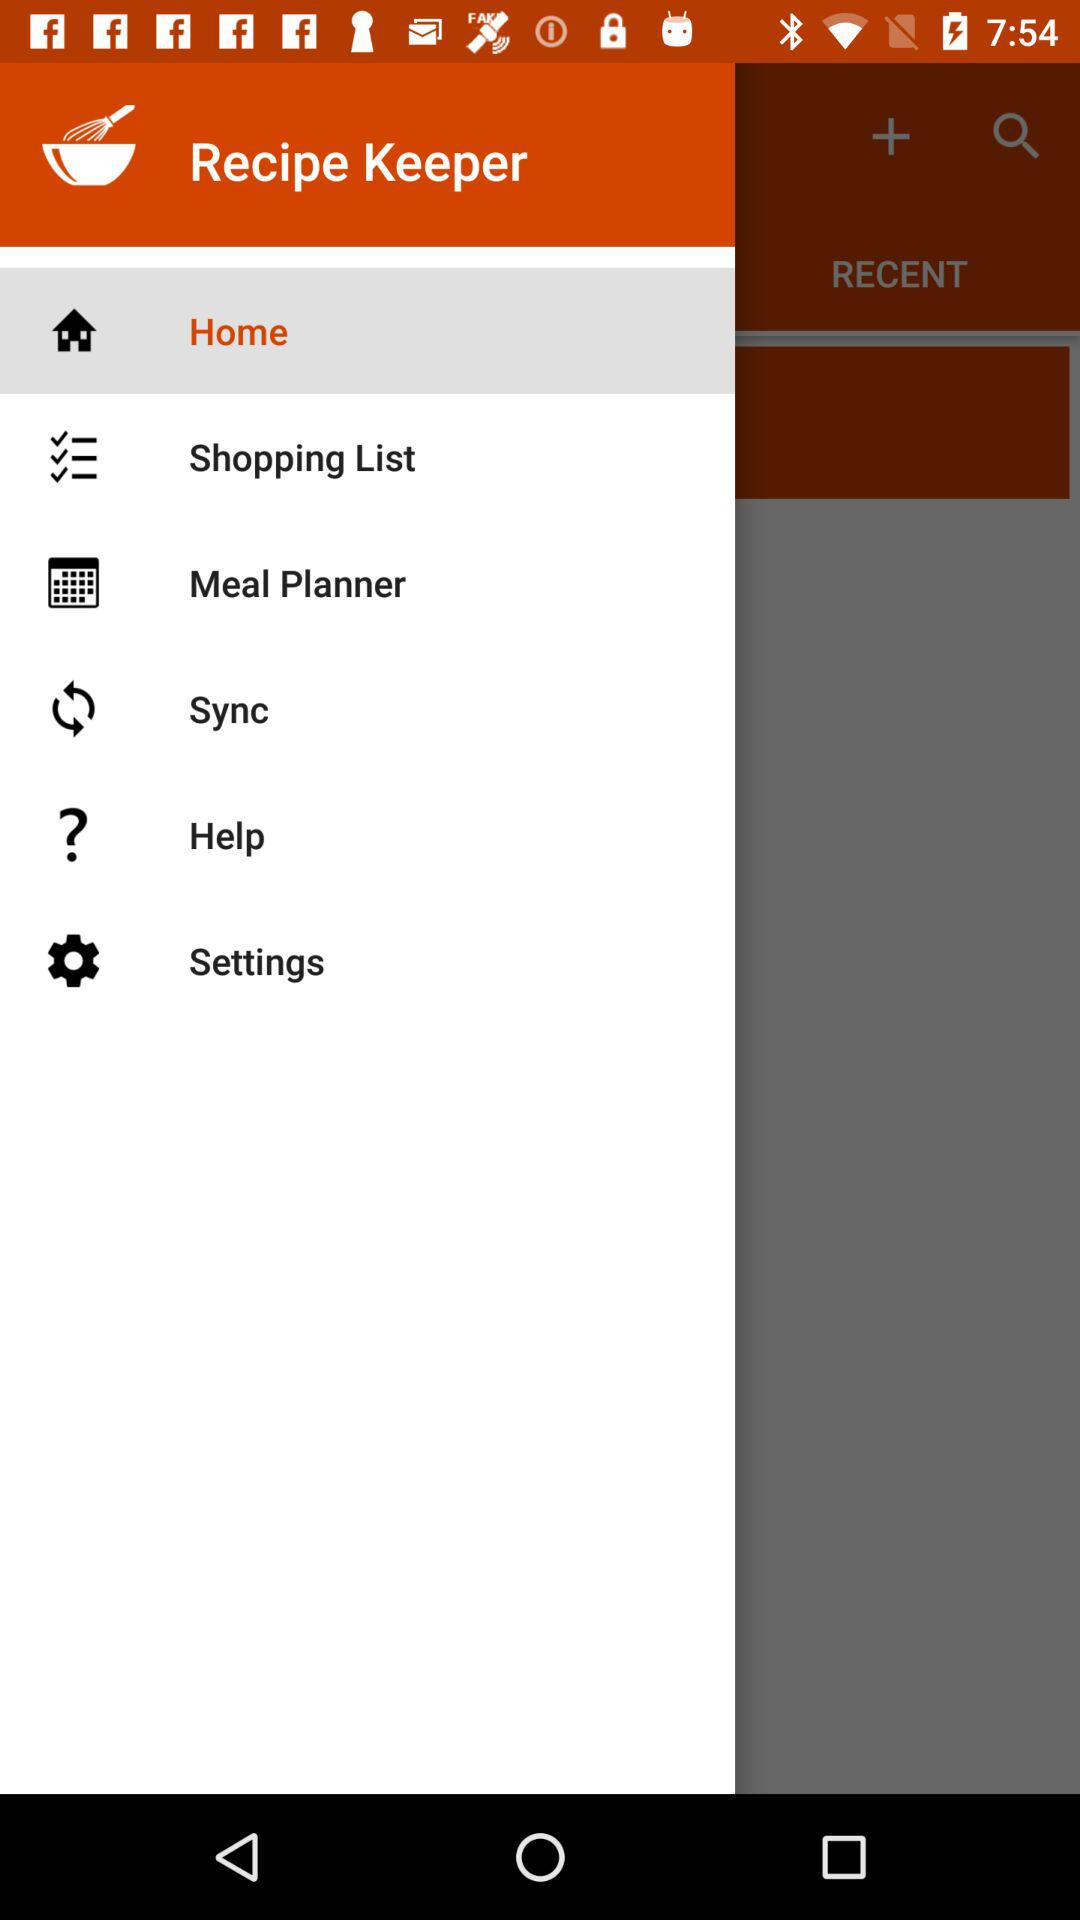What is the application name? The application name is "Recipe Keeper". 